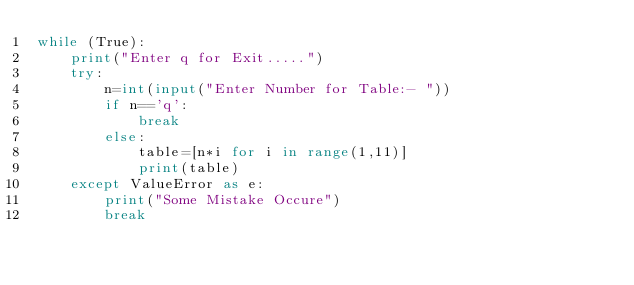Convert code to text. <code><loc_0><loc_0><loc_500><loc_500><_Python_>while (True):
    print("Enter q for Exit.....")
    try:
        n=int(input("Enter Number for Table:- "))
        if n=='q':
            break
        else:
            table=[n*i for i in range(1,11)]
            print(table)
    except ValueError as e:
        print("Some Mistake Occure")
        break</code> 